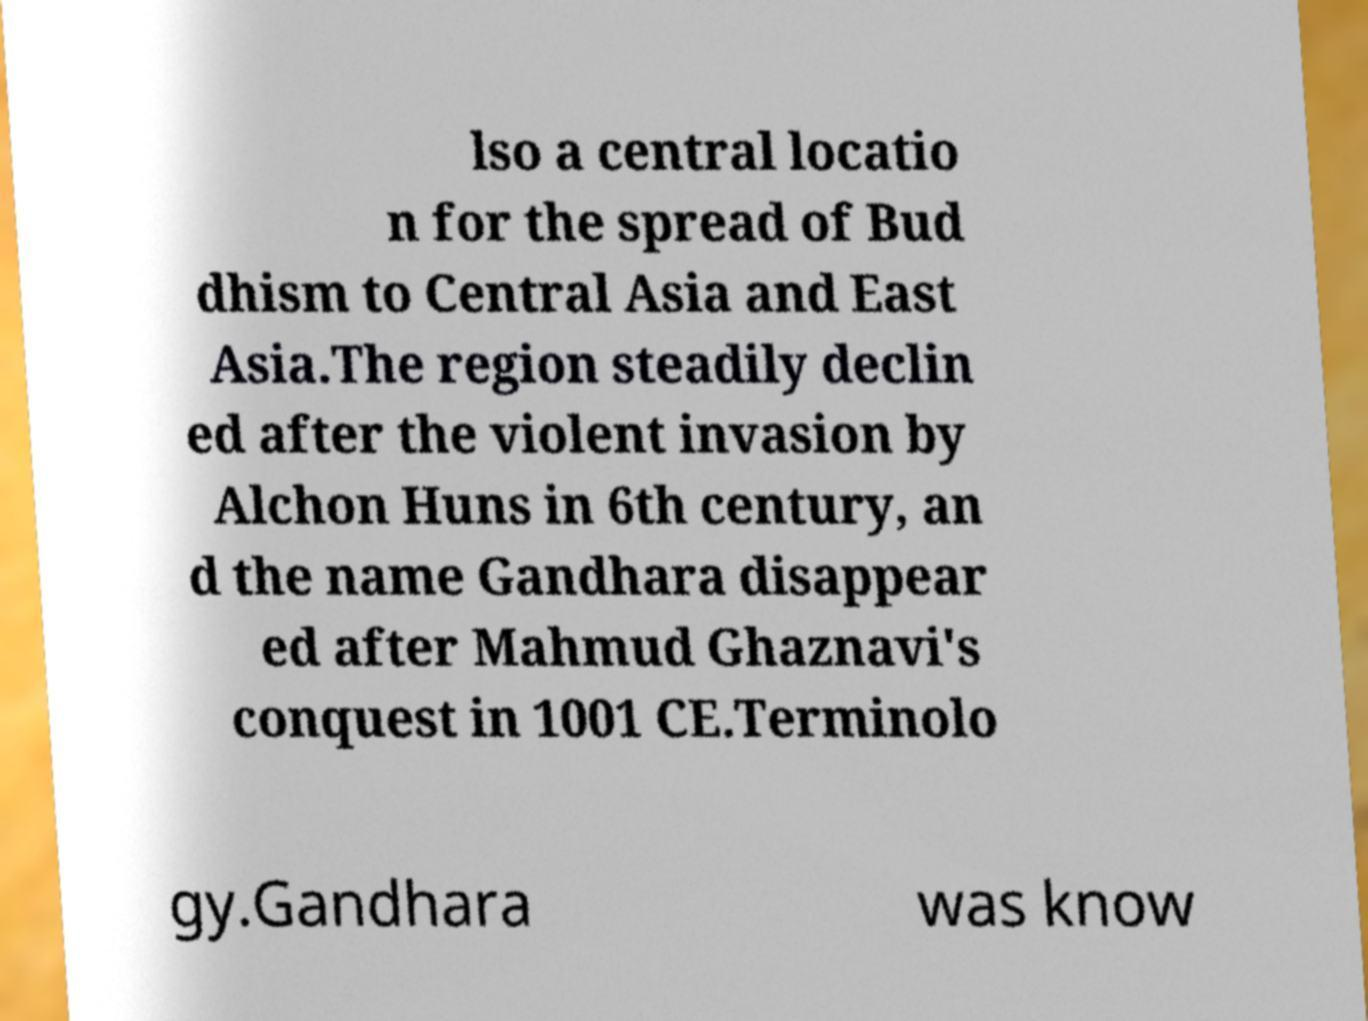For documentation purposes, I need the text within this image transcribed. Could you provide that? lso a central locatio n for the spread of Bud dhism to Central Asia and East Asia.The region steadily declin ed after the violent invasion by Alchon Huns in 6th century, an d the name Gandhara disappear ed after Mahmud Ghaznavi's conquest in 1001 CE.Terminolo gy.Gandhara was know 